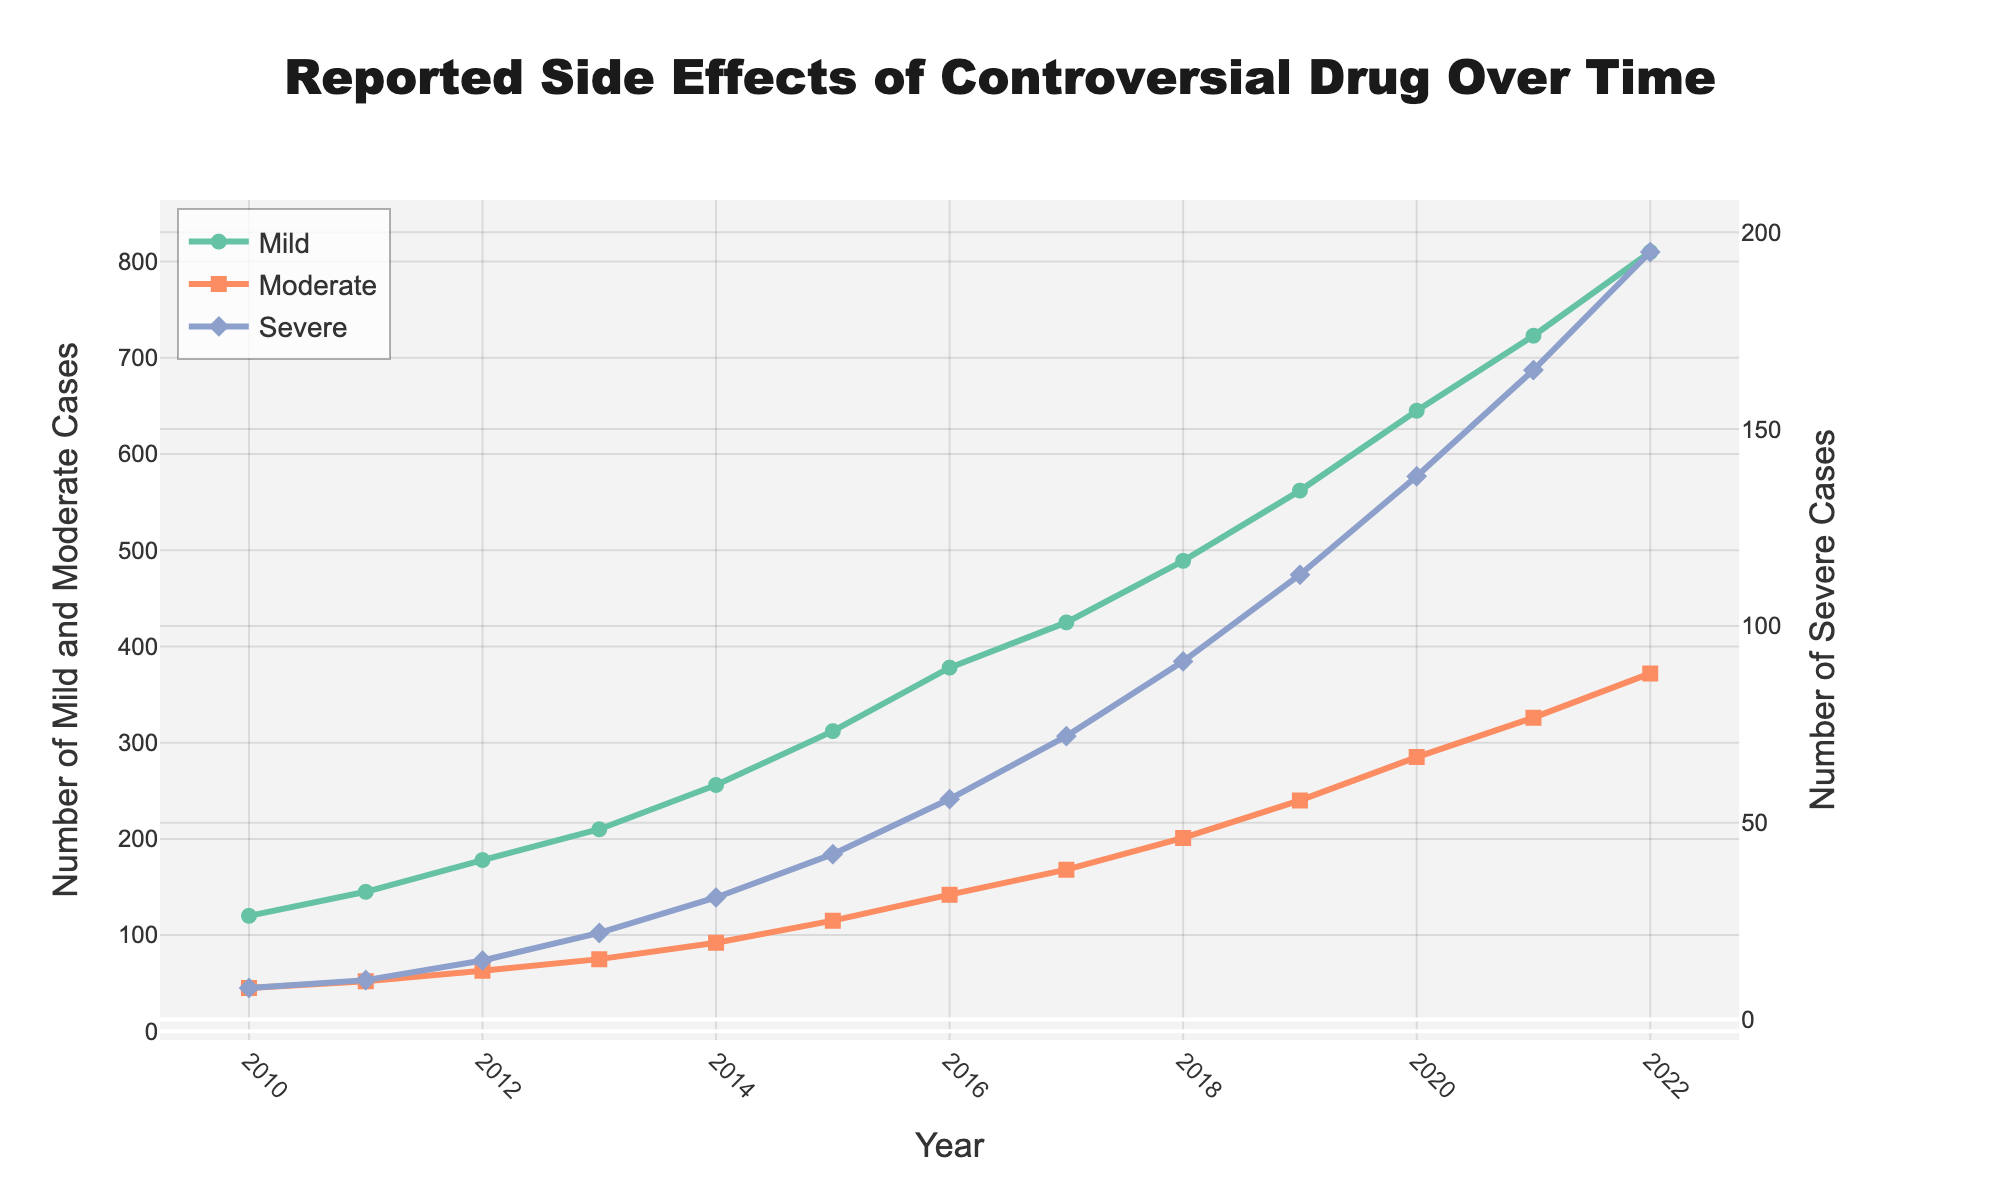what year saw the highest number of reported severe side effects? Looking at the figure, the line for Severe side effects has the highest point in 2022.
Answer: 2022 how many more severe cases were reported in 2021 compared to 2016? In 2021, the number of Severe cases reported is 165. In 2016, it is 56. The difference is 165 - 56 = 109.
Answer: 109 what is the trend of mild cases from 2010 to 2022? The figure shows a rising trend for Mild cases over the years, with the line consistently moving upwards.
Answer: Increasing compare the number of moderate and severe cases in 2014. In 2014, the number of Moderate cases is 92 and Severe cases is 31. Comparing these, Moderate cases are higher than Severe cases.
Answer: Moderate cases higher in which year did moderate cases first exceed 150? The figure shows that in 2017, the number of Moderate cases climbed to 168, the first time it exceeded 150.
Answer: 2017 what is the average number of mild cases reported between 2012 and 2016 inclusive? The figures for Mild cases between 2012 and 2016 are 178, 210, 256, 312, and 378. Added together, they are 1334, and their average is 1334 / 5 = 266.8
Answer: 266.8 did the number of severe cases ever decrease between two consecutive years? Checking the figure, the Severe cases line shows a constant increase every year without any drop between consecutive years.
Answer: No compare the increase in mild cases from 2010 to 2011 with the increase from 2011 to 2012. From 2010 to 2011, Mild cases increased from 120 to 145, an increase of 25. From 2011 to 2012, it increased from 145 to 178, an increase of 33. The increase from 2011 to 2012 is greater.
Answer: 33 is greater than 25 how many years did it take for the number of moderate cases to double from the initial count in 2010? Moderate cases in 2010 were 45. Doubling that is 90. In 2014, Moderate cases reached 92, thus taking 4 years to double.
Answer: 4 years compare the slopes of the lines representing mild and moderate case trends. The line for Mild cases has a steeper and more rapid rise compared to the Moderate cases, indicating a faster rate of increase.
Answer: Mild cases steeper 